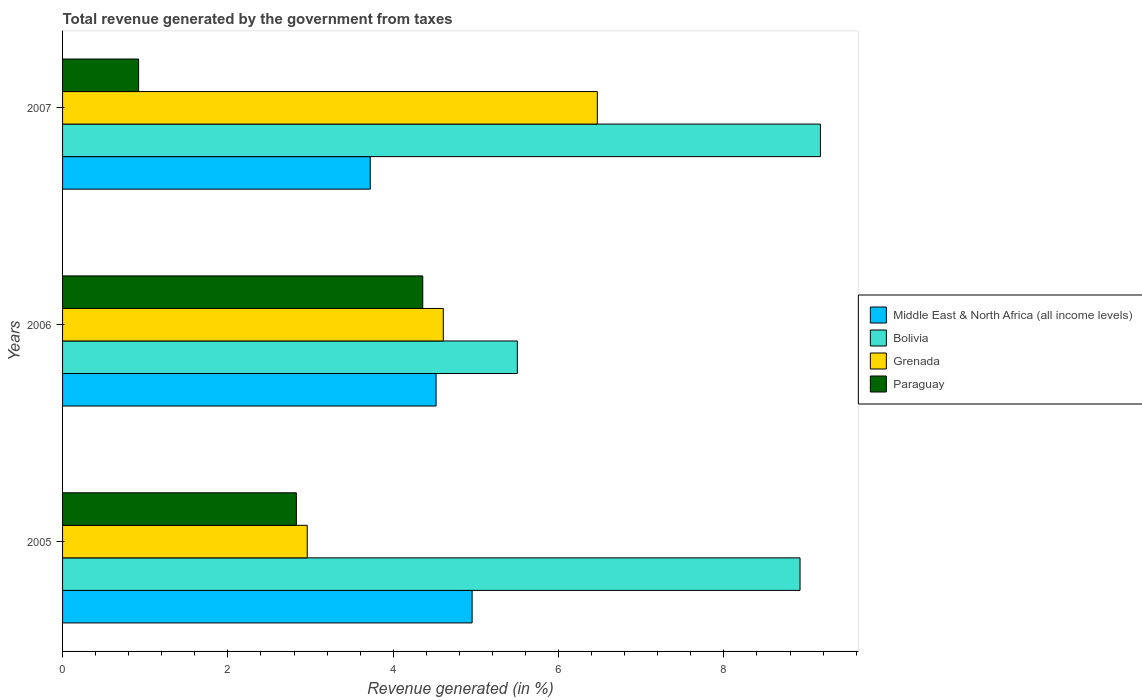Are the number of bars per tick equal to the number of legend labels?
Offer a terse response. Yes. Are the number of bars on each tick of the Y-axis equal?
Ensure brevity in your answer.  Yes. How many bars are there on the 1st tick from the top?
Provide a succinct answer. 4. How many bars are there on the 3rd tick from the bottom?
Your answer should be very brief. 4. What is the label of the 2nd group of bars from the top?
Give a very brief answer. 2006. In how many cases, is the number of bars for a given year not equal to the number of legend labels?
Your answer should be very brief. 0. What is the total revenue generated in Grenada in 2005?
Keep it short and to the point. 2.96. Across all years, what is the maximum total revenue generated in Grenada?
Your answer should be compact. 6.47. Across all years, what is the minimum total revenue generated in Grenada?
Your answer should be very brief. 2.96. In which year was the total revenue generated in Bolivia maximum?
Make the answer very short. 2007. In which year was the total revenue generated in Middle East & North Africa (all income levels) minimum?
Provide a succinct answer. 2007. What is the total total revenue generated in Paraguay in the graph?
Provide a succinct answer. 8.11. What is the difference between the total revenue generated in Grenada in 2005 and that in 2007?
Give a very brief answer. -3.51. What is the difference between the total revenue generated in Middle East & North Africa (all income levels) in 2006 and the total revenue generated in Bolivia in 2007?
Offer a very short reply. -4.65. What is the average total revenue generated in Middle East & North Africa (all income levels) per year?
Give a very brief answer. 4.4. In the year 2005, what is the difference between the total revenue generated in Middle East & North Africa (all income levels) and total revenue generated in Bolivia?
Make the answer very short. -3.97. In how many years, is the total revenue generated in Middle East & North Africa (all income levels) greater than 0.4 %?
Your answer should be very brief. 3. What is the ratio of the total revenue generated in Middle East & North Africa (all income levels) in 2006 to that in 2007?
Make the answer very short. 1.21. Is the total revenue generated in Paraguay in 2006 less than that in 2007?
Make the answer very short. No. Is the difference between the total revenue generated in Middle East & North Africa (all income levels) in 2006 and 2007 greater than the difference between the total revenue generated in Bolivia in 2006 and 2007?
Make the answer very short. Yes. What is the difference between the highest and the second highest total revenue generated in Grenada?
Provide a short and direct response. 1.86. What is the difference between the highest and the lowest total revenue generated in Bolivia?
Your answer should be very brief. 3.67. In how many years, is the total revenue generated in Paraguay greater than the average total revenue generated in Paraguay taken over all years?
Make the answer very short. 2. Is it the case that in every year, the sum of the total revenue generated in Grenada and total revenue generated in Middle East & North Africa (all income levels) is greater than the sum of total revenue generated in Bolivia and total revenue generated in Paraguay?
Offer a very short reply. No. What does the 2nd bar from the bottom in 2007 represents?
Provide a short and direct response. Bolivia. Is it the case that in every year, the sum of the total revenue generated in Bolivia and total revenue generated in Middle East & North Africa (all income levels) is greater than the total revenue generated in Grenada?
Your answer should be very brief. Yes. Are all the bars in the graph horizontal?
Make the answer very short. Yes. How many years are there in the graph?
Keep it short and to the point. 3. Are the values on the major ticks of X-axis written in scientific E-notation?
Keep it short and to the point. No. Does the graph contain grids?
Offer a very short reply. No. Where does the legend appear in the graph?
Give a very brief answer. Center right. What is the title of the graph?
Ensure brevity in your answer.  Total revenue generated by the government from taxes. What is the label or title of the X-axis?
Give a very brief answer. Revenue generated (in %). What is the Revenue generated (in %) in Middle East & North Africa (all income levels) in 2005?
Provide a short and direct response. 4.95. What is the Revenue generated (in %) in Bolivia in 2005?
Provide a succinct answer. 8.92. What is the Revenue generated (in %) in Grenada in 2005?
Give a very brief answer. 2.96. What is the Revenue generated (in %) in Paraguay in 2005?
Your answer should be compact. 2.83. What is the Revenue generated (in %) in Middle East & North Africa (all income levels) in 2006?
Provide a short and direct response. 4.52. What is the Revenue generated (in %) in Bolivia in 2006?
Offer a terse response. 5.5. What is the Revenue generated (in %) of Grenada in 2006?
Offer a very short reply. 4.61. What is the Revenue generated (in %) in Paraguay in 2006?
Provide a short and direct response. 4.36. What is the Revenue generated (in %) of Middle East & North Africa (all income levels) in 2007?
Your answer should be very brief. 3.72. What is the Revenue generated (in %) of Bolivia in 2007?
Your response must be concise. 9.17. What is the Revenue generated (in %) in Grenada in 2007?
Provide a succinct answer. 6.47. What is the Revenue generated (in %) in Paraguay in 2007?
Ensure brevity in your answer.  0.92. Across all years, what is the maximum Revenue generated (in %) in Middle East & North Africa (all income levels)?
Provide a succinct answer. 4.95. Across all years, what is the maximum Revenue generated (in %) of Bolivia?
Provide a short and direct response. 9.17. Across all years, what is the maximum Revenue generated (in %) of Grenada?
Provide a succinct answer. 6.47. Across all years, what is the maximum Revenue generated (in %) of Paraguay?
Keep it short and to the point. 4.36. Across all years, what is the minimum Revenue generated (in %) in Middle East & North Africa (all income levels)?
Provide a short and direct response. 3.72. Across all years, what is the minimum Revenue generated (in %) of Bolivia?
Give a very brief answer. 5.5. Across all years, what is the minimum Revenue generated (in %) of Grenada?
Keep it short and to the point. 2.96. Across all years, what is the minimum Revenue generated (in %) of Paraguay?
Give a very brief answer. 0.92. What is the total Revenue generated (in %) of Middle East & North Africa (all income levels) in the graph?
Your answer should be very brief. 13.19. What is the total Revenue generated (in %) of Bolivia in the graph?
Your answer should be compact. 23.59. What is the total Revenue generated (in %) in Grenada in the graph?
Make the answer very short. 14.03. What is the total Revenue generated (in %) in Paraguay in the graph?
Ensure brevity in your answer.  8.11. What is the difference between the Revenue generated (in %) of Middle East & North Africa (all income levels) in 2005 and that in 2006?
Offer a very short reply. 0.44. What is the difference between the Revenue generated (in %) in Bolivia in 2005 and that in 2006?
Give a very brief answer. 3.42. What is the difference between the Revenue generated (in %) of Grenada in 2005 and that in 2006?
Your response must be concise. -1.65. What is the difference between the Revenue generated (in %) of Paraguay in 2005 and that in 2006?
Your answer should be very brief. -1.53. What is the difference between the Revenue generated (in %) of Middle East & North Africa (all income levels) in 2005 and that in 2007?
Ensure brevity in your answer.  1.23. What is the difference between the Revenue generated (in %) in Bolivia in 2005 and that in 2007?
Offer a very short reply. -0.25. What is the difference between the Revenue generated (in %) in Grenada in 2005 and that in 2007?
Your response must be concise. -3.51. What is the difference between the Revenue generated (in %) of Paraguay in 2005 and that in 2007?
Make the answer very short. 1.91. What is the difference between the Revenue generated (in %) in Middle East & North Africa (all income levels) in 2006 and that in 2007?
Make the answer very short. 0.8. What is the difference between the Revenue generated (in %) of Bolivia in 2006 and that in 2007?
Offer a very short reply. -3.67. What is the difference between the Revenue generated (in %) of Grenada in 2006 and that in 2007?
Keep it short and to the point. -1.86. What is the difference between the Revenue generated (in %) in Paraguay in 2006 and that in 2007?
Provide a succinct answer. 3.44. What is the difference between the Revenue generated (in %) in Middle East & North Africa (all income levels) in 2005 and the Revenue generated (in %) in Bolivia in 2006?
Your response must be concise. -0.55. What is the difference between the Revenue generated (in %) in Middle East & North Africa (all income levels) in 2005 and the Revenue generated (in %) in Grenada in 2006?
Make the answer very short. 0.35. What is the difference between the Revenue generated (in %) in Middle East & North Africa (all income levels) in 2005 and the Revenue generated (in %) in Paraguay in 2006?
Your response must be concise. 0.6. What is the difference between the Revenue generated (in %) in Bolivia in 2005 and the Revenue generated (in %) in Grenada in 2006?
Make the answer very short. 4.32. What is the difference between the Revenue generated (in %) in Bolivia in 2005 and the Revenue generated (in %) in Paraguay in 2006?
Keep it short and to the point. 4.56. What is the difference between the Revenue generated (in %) in Grenada in 2005 and the Revenue generated (in %) in Paraguay in 2006?
Ensure brevity in your answer.  -1.4. What is the difference between the Revenue generated (in %) in Middle East & North Africa (all income levels) in 2005 and the Revenue generated (in %) in Bolivia in 2007?
Give a very brief answer. -4.21. What is the difference between the Revenue generated (in %) in Middle East & North Africa (all income levels) in 2005 and the Revenue generated (in %) in Grenada in 2007?
Make the answer very short. -1.51. What is the difference between the Revenue generated (in %) of Middle East & North Africa (all income levels) in 2005 and the Revenue generated (in %) of Paraguay in 2007?
Ensure brevity in your answer.  4.03. What is the difference between the Revenue generated (in %) in Bolivia in 2005 and the Revenue generated (in %) in Grenada in 2007?
Provide a short and direct response. 2.45. What is the difference between the Revenue generated (in %) of Bolivia in 2005 and the Revenue generated (in %) of Paraguay in 2007?
Give a very brief answer. 8. What is the difference between the Revenue generated (in %) of Grenada in 2005 and the Revenue generated (in %) of Paraguay in 2007?
Your answer should be compact. 2.04. What is the difference between the Revenue generated (in %) of Middle East & North Africa (all income levels) in 2006 and the Revenue generated (in %) of Bolivia in 2007?
Offer a very short reply. -4.65. What is the difference between the Revenue generated (in %) of Middle East & North Africa (all income levels) in 2006 and the Revenue generated (in %) of Grenada in 2007?
Your answer should be compact. -1.95. What is the difference between the Revenue generated (in %) in Middle East & North Africa (all income levels) in 2006 and the Revenue generated (in %) in Paraguay in 2007?
Make the answer very short. 3.6. What is the difference between the Revenue generated (in %) of Bolivia in 2006 and the Revenue generated (in %) of Grenada in 2007?
Offer a terse response. -0.97. What is the difference between the Revenue generated (in %) of Bolivia in 2006 and the Revenue generated (in %) of Paraguay in 2007?
Offer a terse response. 4.58. What is the difference between the Revenue generated (in %) in Grenada in 2006 and the Revenue generated (in %) in Paraguay in 2007?
Offer a very short reply. 3.69. What is the average Revenue generated (in %) of Middle East & North Africa (all income levels) per year?
Provide a succinct answer. 4.4. What is the average Revenue generated (in %) in Bolivia per year?
Give a very brief answer. 7.86. What is the average Revenue generated (in %) in Grenada per year?
Offer a terse response. 4.68. What is the average Revenue generated (in %) in Paraguay per year?
Ensure brevity in your answer.  2.7. In the year 2005, what is the difference between the Revenue generated (in %) of Middle East & North Africa (all income levels) and Revenue generated (in %) of Bolivia?
Offer a very short reply. -3.97. In the year 2005, what is the difference between the Revenue generated (in %) of Middle East & North Africa (all income levels) and Revenue generated (in %) of Grenada?
Your response must be concise. 1.99. In the year 2005, what is the difference between the Revenue generated (in %) in Middle East & North Africa (all income levels) and Revenue generated (in %) in Paraguay?
Offer a very short reply. 2.13. In the year 2005, what is the difference between the Revenue generated (in %) of Bolivia and Revenue generated (in %) of Grenada?
Make the answer very short. 5.96. In the year 2005, what is the difference between the Revenue generated (in %) in Bolivia and Revenue generated (in %) in Paraguay?
Give a very brief answer. 6.09. In the year 2005, what is the difference between the Revenue generated (in %) in Grenada and Revenue generated (in %) in Paraguay?
Provide a succinct answer. 0.13. In the year 2006, what is the difference between the Revenue generated (in %) of Middle East & North Africa (all income levels) and Revenue generated (in %) of Bolivia?
Your response must be concise. -0.98. In the year 2006, what is the difference between the Revenue generated (in %) of Middle East & North Africa (all income levels) and Revenue generated (in %) of Grenada?
Offer a terse response. -0.09. In the year 2006, what is the difference between the Revenue generated (in %) in Middle East & North Africa (all income levels) and Revenue generated (in %) in Paraguay?
Give a very brief answer. 0.16. In the year 2006, what is the difference between the Revenue generated (in %) in Bolivia and Revenue generated (in %) in Grenada?
Give a very brief answer. 0.9. In the year 2006, what is the difference between the Revenue generated (in %) in Bolivia and Revenue generated (in %) in Paraguay?
Make the answer very short. 1.14. In the year 2006, what is the difference between the Revenue generated (in %) in Grenada and Revenue generated (in %) in Paraguay?
Provide a succinct answer. 0.25. In the year 2007, what is the difference between the Revenue generated (in %) in Middle East & North Africa (all income levels) and Revenue generated (in %) in Bolivia?
Your answer should be very brief. -5.45. In the year 2007, what is the difference between the Revenue generated (in %) of Middle East & North Africa (all income levels) and Revenue generated (in %) of Grenada?
Ensure brevity in your answer.  -2.75. In the year 2007, what is the difference between the Revenue generated (in %) in Middle East & North Africa (all income levels) and Revenue generated (in %) in Paraguay?
Offer a terse response. 2.8. In the year 2007, what is the difference between the Revenue generated (in %) of Bolivia and Revenue generated (in %) of Grenada?
Give a very brief answer. 2.7. In the year 2007, what is the difference between the Revenue generated (in %) in Bolivia and Revenue generated (in %) in Paraguay?
Give a very brief answer. 8.25. In the year 2007, what is the difference between the Revenue generated (in %) in Grenada and Revenue generated (in %) in Paraguay?
Your answer should be compact. 5.55. What is the ratio of the Revenue generated (in %) in Middle East & North Africa (all income levels) in 2005 to that in 2006?
Give a very brief answer. 1.1. What is the ratio of the Revenue generated (in %) of Bolivia in 2005 to that in 2006?
Provide a succinct answer. 1.62. What is the ratio of the Revenue generated (in %) of Grenada in 2005 to that in 2006?
Give a very brief answer. 0.64. What is the ratio of the Revenue generated (in %) in Paraguay in 2005 to that in 2006?
Give a very brief answer. 0.65. What is the ratio of the Revenue generated (in %) of Middle East & North Africa (all income levels) in 2005 to that in 2007?
Offer a terse response. 1.33. What is the ratio of the Revenue generated (in %) in Bolivia in 2005 to that in 2007?
Your answer should be compact. 0.97. What is the ratio of the Revenue generated (in %) in Grenada in 2005 to that in 2007?
Provide a short and direct response. 0.46. What is the ratio of the Revenue generated (in %) of Paraguay in 2005 to that in 2007?
Provide a succinct answer. 3.07. What is the ratio of the Revenue generated (in %) of Middle East & North Africa (all income levels) in 2006 to that in 2007?
Provide a short and direct response. 1.21. What is the ratio of the Revenue generated (in %) of Bolivia in 2006 to that in 2007?
Keep it short and to the point. 0.6. What is the ratio of the Revenue generated (in %) in Grenada in 2006 to that in 2007?
Provide a short and direct response. 0.71. What is the ratio of the Revenue generated (in %) of Paraguay in 2006 to that in 2007?
Give a very brief answer. 4.74. What is the difference between the highest and the second highest Revenue generated (in %) in Middle East & North Africa (all income levels)?
Offer a very short reply. 0.44. What is the difference between the highest and the second highest Revenue generated (in %) of Bolivia?
Your answer should be very brief. 0.25. What is the difference between the highest and the second highest Revenue generated (in %) in Grenada?
Your answer should be compact. 1.86. What is the difference between the highest and the second highest Revenue generated (in %) of Paraguay?
Your answer should be compact. 1.53. What is the difference between the highest and the lowest Revenue generated (in %) in Middle East & North Africa (all income levels)?
Your response must be concise. 1.23. What is the difference between the highest and the lowest Revenue generated (in %) in Bolivia?
Your answer should be compact. 3.67. What is the difference between the highest and the lowest Revenue generated (in %) in Grenada?
Make the answer very short. 3.51. What is the difference between the highest and the lowest Revenue generated (in %) in Paraguay?
Offer a very short reply. 3.44. 